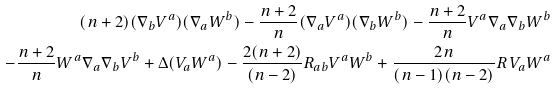<formula> <loc_0><loc_0><loc_500><loc_500>( n + 2 ) ( \nabla _ { b } V ^ { a } ) ( \nabla _ { a } W ^ { b } ) - \frac { n + 2 } { n } ( \nabla _ { a } V ^ { a } ) ( \nabla _ { b } W ^ { b } ) - \frac { n + 2 } { n } V ^ { a } \nabla _ { a } \nabla _ { b } W ^ { b } \\ - \frac { n + 2 } { n } W ^ { a } \nabla _ { a } \nabla _ { b } V ^ { b } + \Delta ( V _ { a } W ^ { a } ) - \frac { 2 ( n + 2 ) } { ( n - 2 ) } R _ { a b } V ^ { a } W ^ { b } + \frac { 2 n } { ( n - 1 ) ( n - 2 ) } R \, V _ { a } W ^ { a }</formula> 